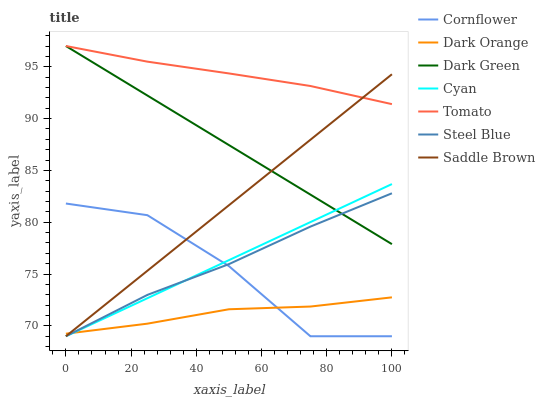Does Dark Orange have the minimum area under the curve?
Answer yes or no. Yes. Does Tomato have the maximum area under the curve?
Answer yes or no. Yes. Does Cornflower have the minimum area under the curve?
Answer yes or no. No. Does Cornflower have the maximum area under the curve?
Answer yes or no. No. Is Cyan the smoothest?
Answer yes or no. Yes. Is Cornflower the roughest?
Answer yes or no. Yes. Is Dark Orange the smoothest?
Answer yes or no. No. Is Dark Orange the roughest?
Answer yes or no. No. Does Cornflower have the lowest value?
Answer yes or no. Yes. Does Dark Orange have the lowest value?
Answer yes or no. No. Does Dark Green have the highest value?
Answer yes or no. Yes. Does Cornflower have the highest value?
Answer yes or no. No. Is Cornflower less than Dark Green?
Answer yes or no. Yes. Is Tomato greater than Cornflower?
Answer yes or no. Yes. Does Saddle Brown intersect Cyan?
Answer yes or no. Yes. Is Saddle Brown less than Cyan?
Answer yes or no. No. Is Saddle Brown greater than Cyan?
Answer yes or no. No. Does Cornflower intersect Dark Green?
Answer yes or no. No. 